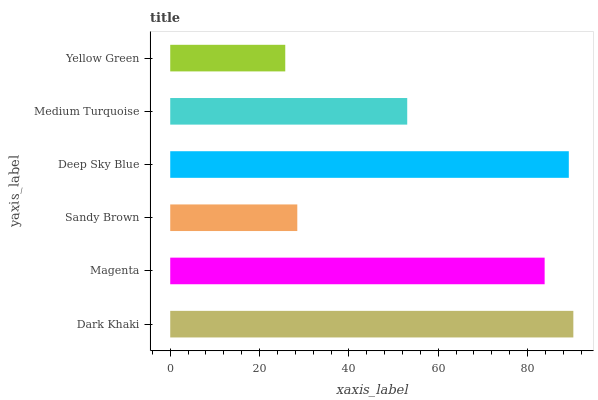Is Yellow Green the minimum?
Answer yes or no. Yes. Is Dark Khaki the maximum?
Answer yes or no. Yes. Is Magenta the minimum?
Answer yes or no. No. Is Magenta the maximum?
Answer yes or no. No. Is Dark Khaki greater than Magenta?
Answer yes or no. Yes. Is Magenta less than Dark Khaki?
Answer yes or no. Yes. Is Magenta greater than Dark Khaki?
Answer yes or no. No. Is Dark Khaki less than Magenta?
Answer yes or no. No. Is Magenta the high median?
Answer yes or no. Yes. Is Medium Turquoise the low median?
Answer yes or no. Yes. Is Deep Sky Blue the high median?
Answer yes or no. No. Is Sandy Brown the low median?
Answer yes or no. No. 